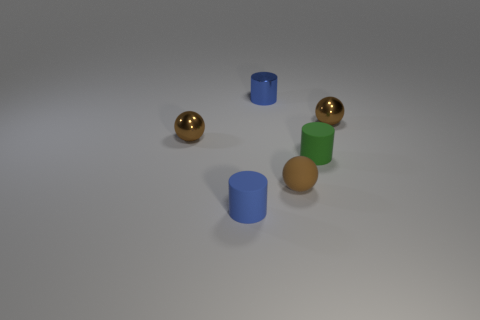Add 3 brown matte cylinders. How many objects exist? 9 Add 1 big brown rubber balls. How many big brown rubber balls exist? 1 Subtract 0 gray balls. How many objects are left? 6 Subtract all balls. Subtract all small blue metal things. How many objects are left? 2 Add 2 balls. How many balls are left? 5 